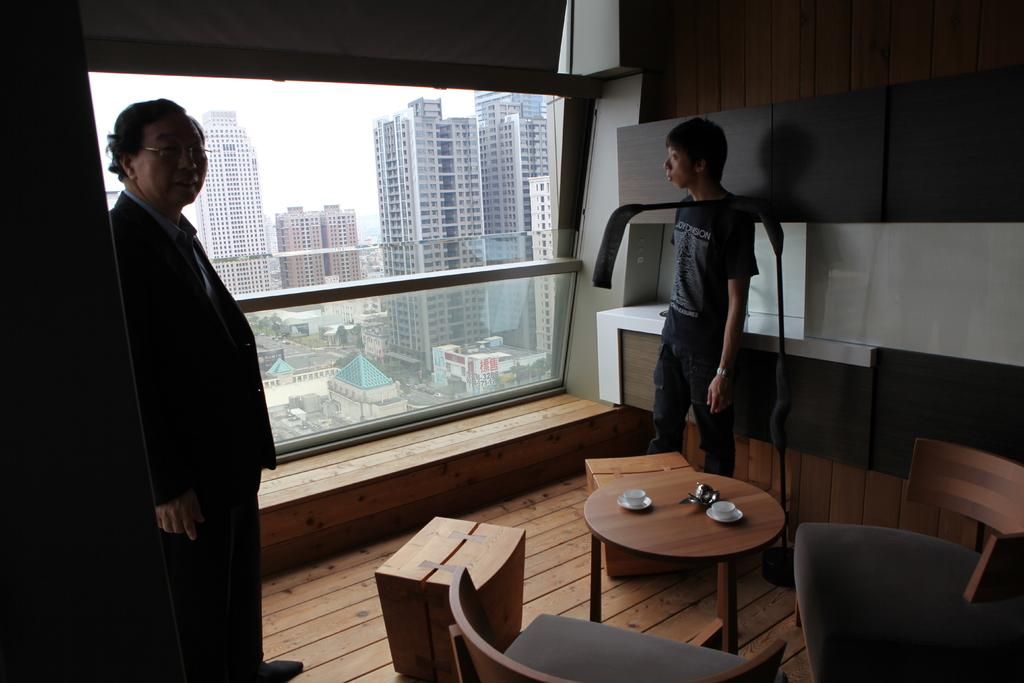How many people are in the image? There are two men in the image. What are the men doing in the image? The men are standing. What is present on the table in the image? There are two cups on the table. What type of furniture is visible in the image? There are two chairs in the image. What other objects can be seen in the image? There are two boxes in the image. What can be seen in the background of the image? There are buildings visible in the background of the image. What type of motion is the story going through in the image? There is no story present in the image, and therefore no motion related to a story can be observed. 